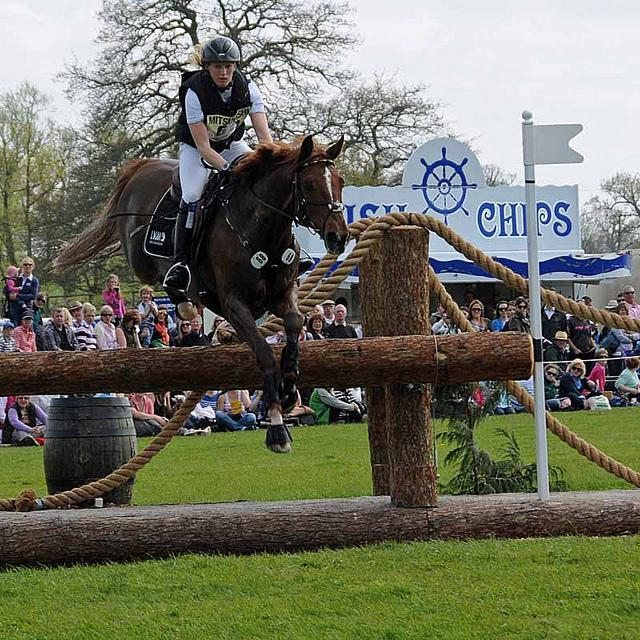What object is in the center of the chips stand logo?

Choices:
A) ship
B) boat
C) wheel
D) potato wheel 